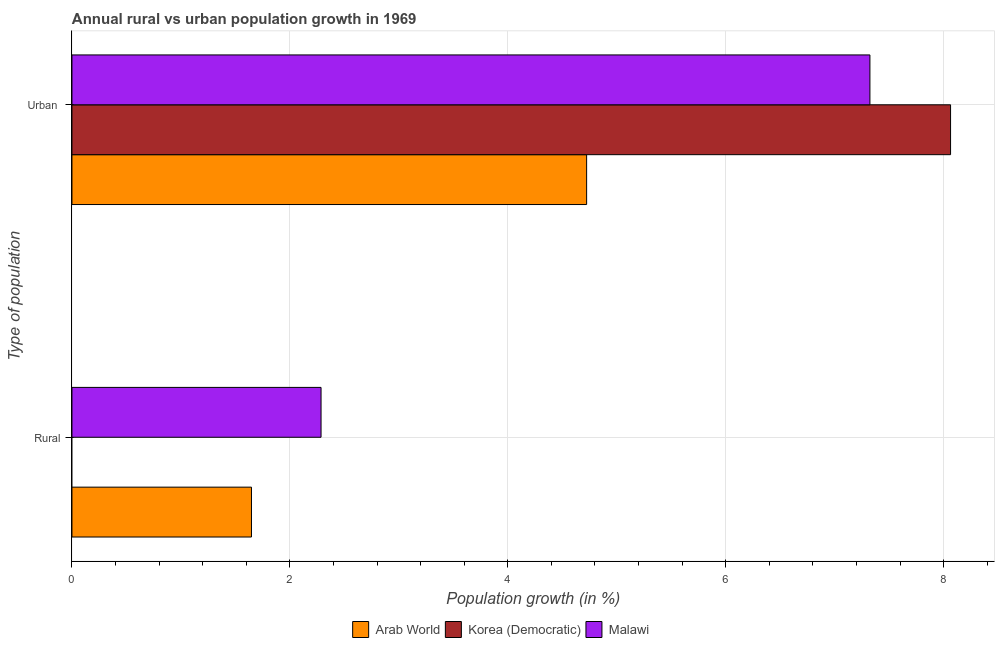How many groups of bars are there?
Provide a short and direct response. 2. Are the number of bars per tick equal to the number of legend labels?
Make the answer very short. No. Are the number of bars on each tick of the Y-axis equal?
Provide a succinct answer. No. What is the label of the 2nd group of bars from the top?
Keep it short and to the point. Rural. What is the urban population growth in Arab World?
Your answer should be very brief. 4.72. Across all countries, what is the maximum rural population growth?
Make the answer very short. 2.29. Across all countries, what is the minimum urban population growth?
Provide a short and direct response. 4.72. In which country was the urban population growth maximum?
Keep it short and to the point. Korea (Democratic). What is the total urban population growth in the graph?
Offer a very short reply. 20.11. What is the difference between the urban population growth in Arab World and that in Malawi?
Keep it short and to the point. -2.6. What is the difference between the rural population growth in Korea (Democratic) and the urban population growth in Arab World?
Your answer should be very brief. -4.72. What is the average rural population growth per country?
Your answer should be compact. 1.31. What is the difference between the rural population growth and urban population growth in Malawi?
Keep it short and to the point. -5.04. In how many countries, is the urban population growth greater than 6.4 %?
Offer a very short reply. 2. What is the ratio of the urban population growth in Arab World to that in Korea (Democratic)?
Make the answer very short. 0.59. Is the rural population growth in Arab World less than that in Malawi?
Give a very brief answer. Yes. Are all the bars in the graph horizontal?
Keep it short and to the point. Yes. How many countries are there in the graph?
Provide a short and direct response. 3. How many legend labels are there?
Offer a terse response. 3. What is the title of the graph?
Provide a succinct answer. Annual rural vs urban population growth in 1969. Does "Macedonia" appear as one of the legend labels in the graph?
Offer a very short reply. No. What is the label or title of the X-axis?
Make the answer very short. Population growth (in %). What is the label or title of the Y-axis?
Your response must be concise. Type of population. What is the Population growth (in %) of Arab World in Rural?
Your answer should be very brief. 1.65. What is the Population growth (in %) in Malawi in Rural?
Your response must be concise. 2.29. What is the Population growth (in %) in Arab World in Urban ?
Make the answer very short. 4.72. What is the Population growth (in %) in Korea (Democratic) in Urban ?
Your response must be concise. 8.06. What is the Population growth (in %) in Malawi in Urban ?
Offer a terse response. 7.32. Across all Type of population, what is the maximum Population growth (in %) in Arab World?
Provide a short and direct response. 4.72. Across all Type of population, what is the maximum Population growth (in %) of Korea (Democratic)?
Ensure brevity in your answer.  8.06. Across all Type of population, what is the maximum Population growth (in %) of Malawi?
Give a very brief answer. 7.32. Across all Type of population, what is the minimum Population growth (in %) of Arab World?
Your answer should be very brief. 1.65. Across all Type of population, what is the minimum Population growth (in %) in Korea (Democratic)?
Make the answer very short. 0. Across all Type of population, what is the minimum Population growth (in %) of Malawi?
Your answer should be very brief. 2.29. What is the total Population growth (in %) in Arab World in the graph?
Make the answer very short. 6.37. What is the total Population growth (in %) of Korea (Democratic) in the graph?
Offer a terse response. 8.06. What is the total Population growth (in %) in Malawi in the graph?
Provide a short and direct response. 9.61. What is the difference between the Population growth (in %) of Arab World in Rural and that in Urban ?
Give a very brief answer. -3.08. What is the difference between the Population growth (in %) of Malawi in Rural and that in Urban ?
Make the answer very short. -5.04. What is the difference between the Population growth (in %) of Arab World in Rural and the Population growth (in %) of Korea (Democratic) in Urban ?
Your answer should be very brief. -6.42. What is the difference between the Population growth (in %) of Arab World in Rural and the Population growth (in %) of Malawi in Urban ?
Provide a short and direct response. -5.68. What is the average Population growth (in %) in Arab World per Type of population?
Keep it short and to the point. 3.19. What is the average Population growth (in %) in Korea (Democratic) per Type of population?
Your answer should be very brief. 4.03. What is the average Population growth (in %) of Malawi per Type of population?
Your answer should be compact. 4.8. What is the difference between the Population growth (in %) in Arab World and Population growth (in %) in Malawi in Rural?
Make the answer very short. -0.64. What is the difference between the Population growth (in %) of Arab World and Population growth (in %) of Korea (Democratic) in Urban ?
Your answer should be compact. -3.34. What is the difference between the Population growth (in %) in Arab World and Population growth (in %) in Malawi in Urban ?
Offer a terse response. -2.6. What is the difference between the Population growth (in %) in Korea (Democratic) and Population growth (in %) in Malawi in Urban ?
Ensure brevity in your answer.  0.74. What is the ratio of the Population growth (in %) of Arab World in Rural to that in Urban ?
Give a very brief answer. 0.35. What is the ratio of the Population growth (in %) in Malawi in Rural to that in Urban ?
Provide a succinct answer. 0.31. What is the difference between the highest and the second highest Population growth (in %) in Arab World?
Your answer should be compact. 3.08. What is the difference between the highest and the second highest Population growth (in %) in Malawi?
Ensure brevity in your answer.  5.04. What is the difference between the highest and the lowest Population growth (in %) of Arab World?
Provide a short and direct response. 3.08. What is the difference between the highest and the lowest Population growth (in %) of Korea (Democratic)?
Provide a short and direct response. 8.06. What is the difference between the highest and the lowest Population growth (in %) in Malawi?
Provide a short and direct response. 5.04. 